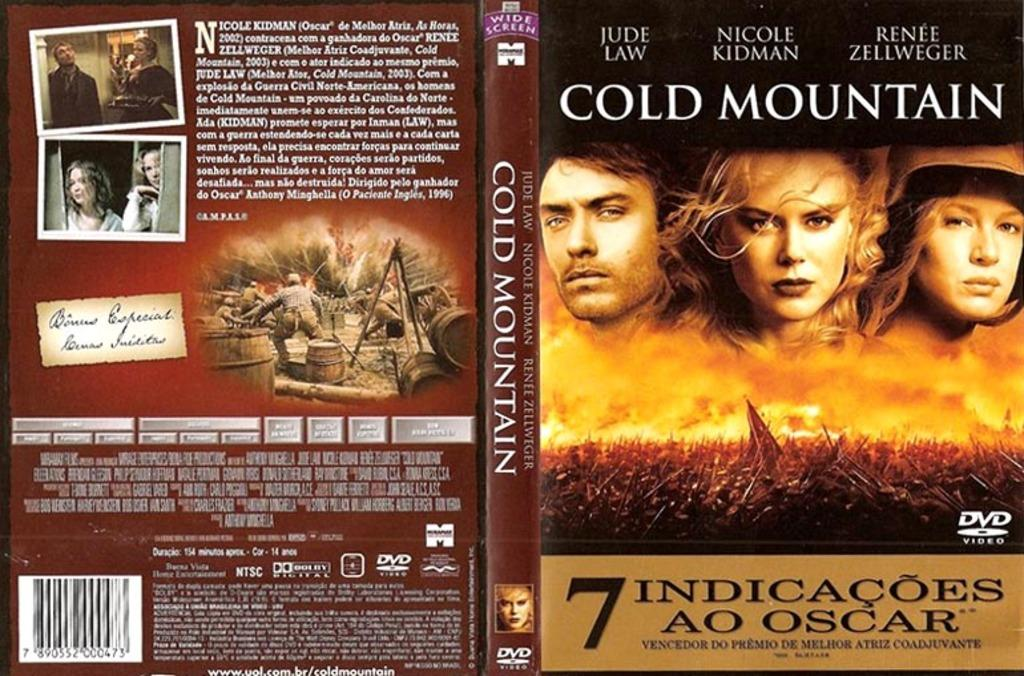What types of images can be seen on the DVD cover? The DVD cover contains photos of people and objects. What other elements are present on the DVD cover besides images? The DVD cover contains words, numbers, and a barcode. What type of coil is used to polish the DVD cover? There is no coil or polishing mentioned in the facts about the DVD cover. How many thumbs are visible on the DVD cover? There is no mention of thumbs on the DVD cover; it contains photos of people and objects, as well as words, numbers, and a barcode. 